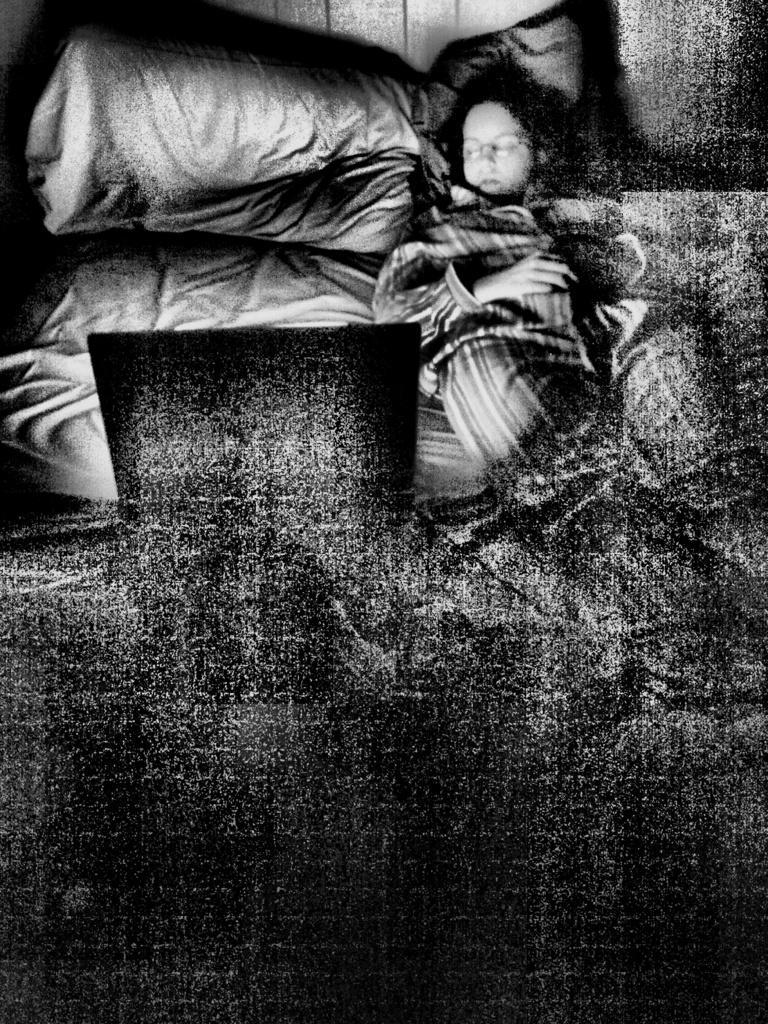In one or two sentences, can you explain what this image depicts? This is an edited black and white image. We can see a person is lying on the bed and behind the bed there is a pillow and a wall. 